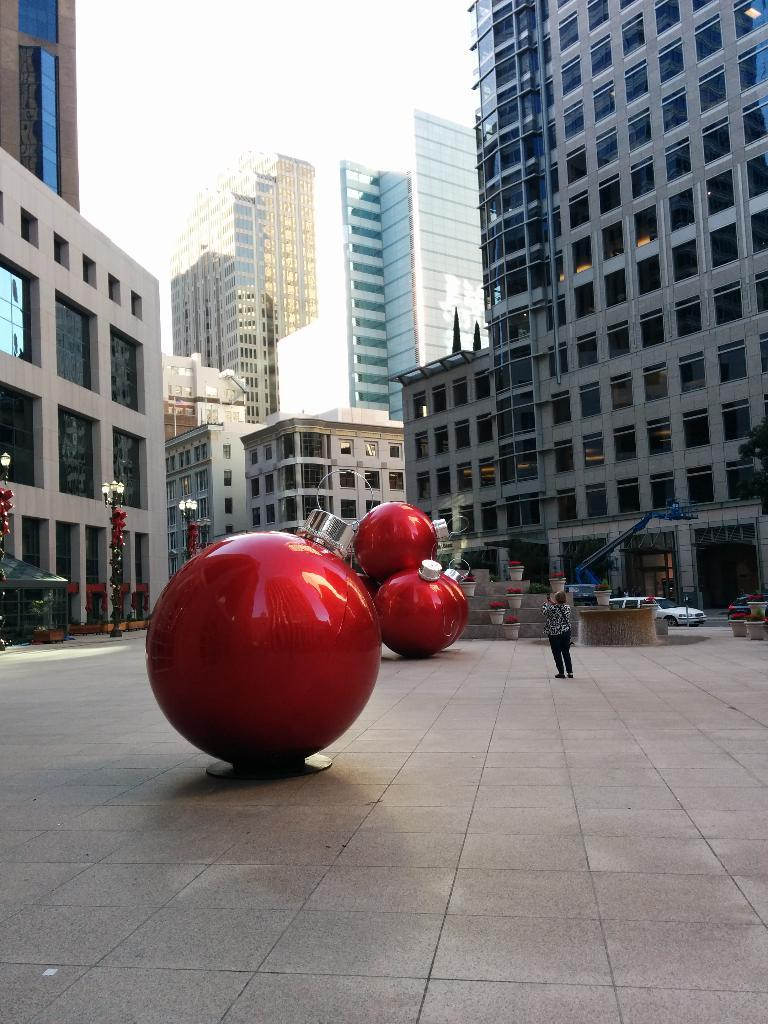What type of structures can be seen in the image? There are buildings in the image. What feature is visible on the buildings? Windows are visible in the image. What type of street furniture is present in the image? Light poles are present in the image. What type of decorative objects can be seen in the image? Flower pots are visible in the image. What type of transportation is present in the image? Vehicles are present in the image. Are there any people visible in the image? Yes, there is at least one person in the image. What part of the natural environment is visible in the image? The sky is visible in the image. What colors are present on the road in the image? There are red and silver color objects on the road. What type of bath can be seen in the image? There is no bath present in the image. What season is it in the image, considering the presence of summer-related objects? There is no specific season mentioned or depicted in the image, as it does not contain any season-related objects or indicators. 